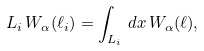<formula> <loc_0><loc_0><loc_500><loc_500>L _ { i } \, W _ { \alpha } ( \ell _ { i } ) = \int _ { L _ { i } } \, d x \, W _ { \alpha } ( \ell ) ,</formula> 